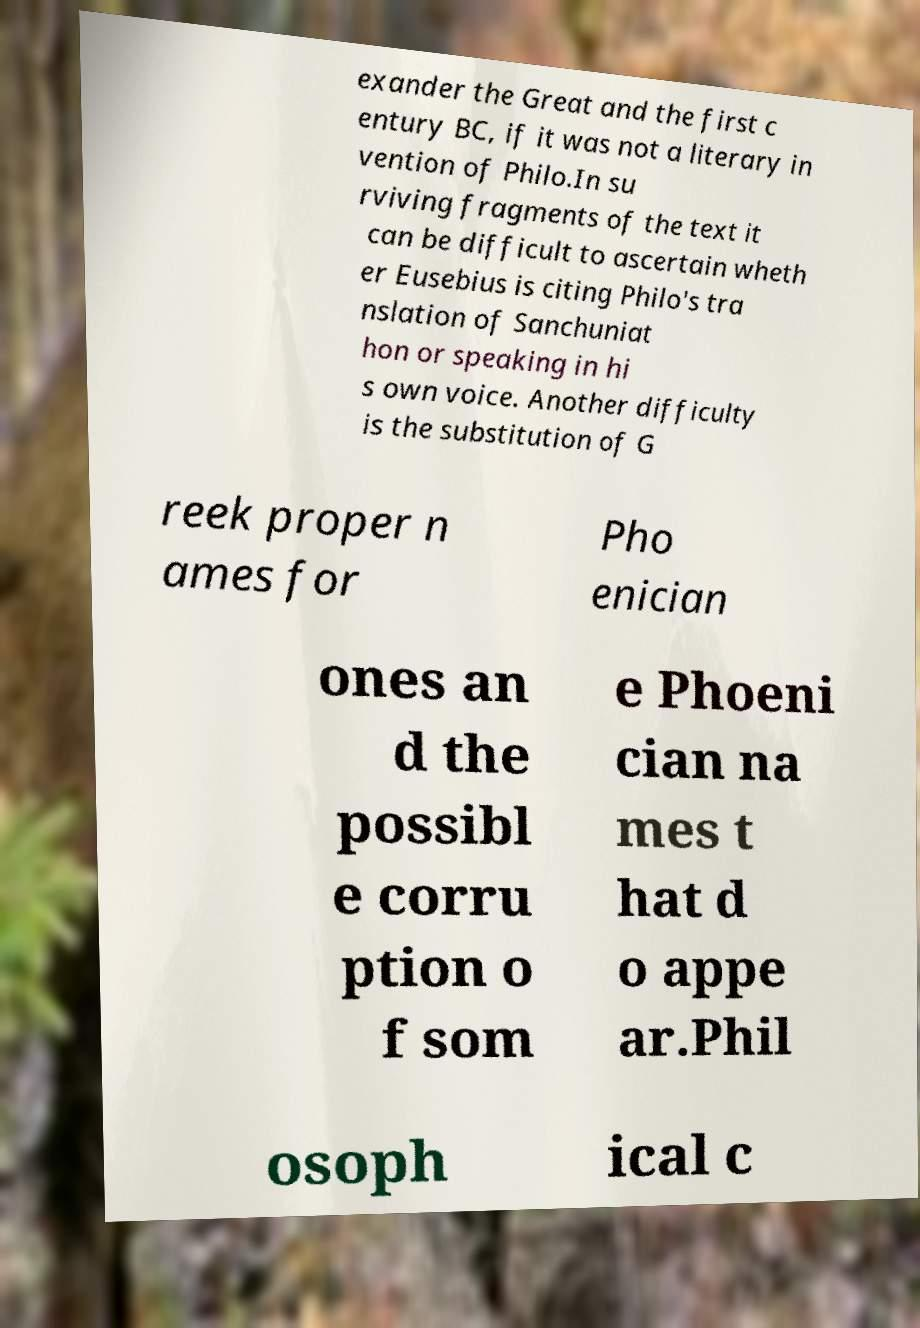Can you accurately transcribe the text from the provided image for me? exander the Great and the first c entury BC, if it was not a literary in vention of Philo.In su rviving fragments of the text it can be difficult to ascertain wheth er Eusebius is citing Philo's tra nslation of Sanchuniat hon or speaking in hi s own voice. Another difficulty is the substitution of G reek proper n ames for Pho enician ones an d the possibl e corru ption o f som e Phoeni cian na mes t hat d o appe ar.Phil osoph ical c 